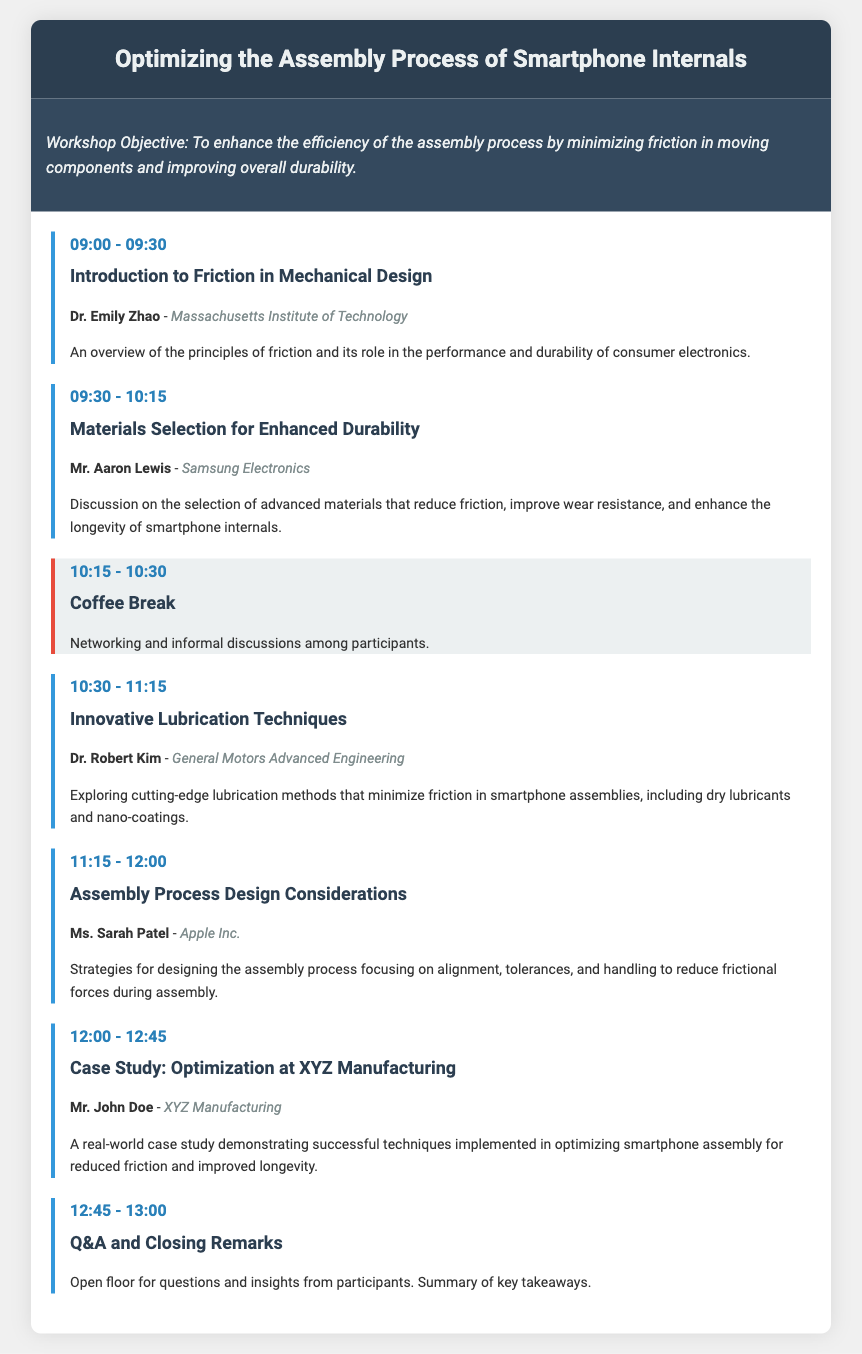What is the title of the workshop? The title of the workshop is provided in the header of the document.
Answer: Optimizing the Assembly Process of Smartphone Internals Who is the presenter for the session on Materials Selection for Enhanced Durability? The presenter is mentioned in the session details for that specific segment.
Answer: Mr. Aaron Lewis What time does the Innovative Lubrication Techniques session start? The session times are listed right before each session title.
Answer: 10:30 What is the main objective of the workshop? The objective is summarized in the objective section of the document.
Answer: To enhance the efficiency of the assembly process by minimizing friction in moving components and improving overall durability Which organization is Dr. Emily Zhao affiliated with? The organization name is specified underneath the presenter’s name in the session details.
Answer: Massachusetts Institute of Technology How long is the Coffee Break scheduled for? The duration of each session or break is given in the time slots provided.
Answer: 15 minutes What is the focus of the Assembly Process Design Considerations session? The focus is indicated in the description of the session details.
Answer: To reduce frictional forces during assembly Which presenter is associated with the case study? The presenter for the case study section is outlined in the session details.
Answer: Mr. John Doe 